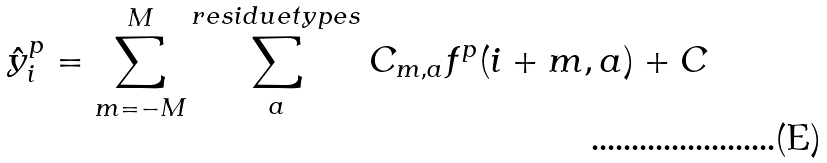Convert formula to latex. <formula><loc_0><loc_0><loc_500><loc_500>\hat { y } _ { i } ^ { p } = \sum _ { m = - M } ^ { M } \sum _ { a } ^ { r e s i d u e t y p e s } C _ { m , a } f ^ { p } ( i + m , a ) + C</formula> 